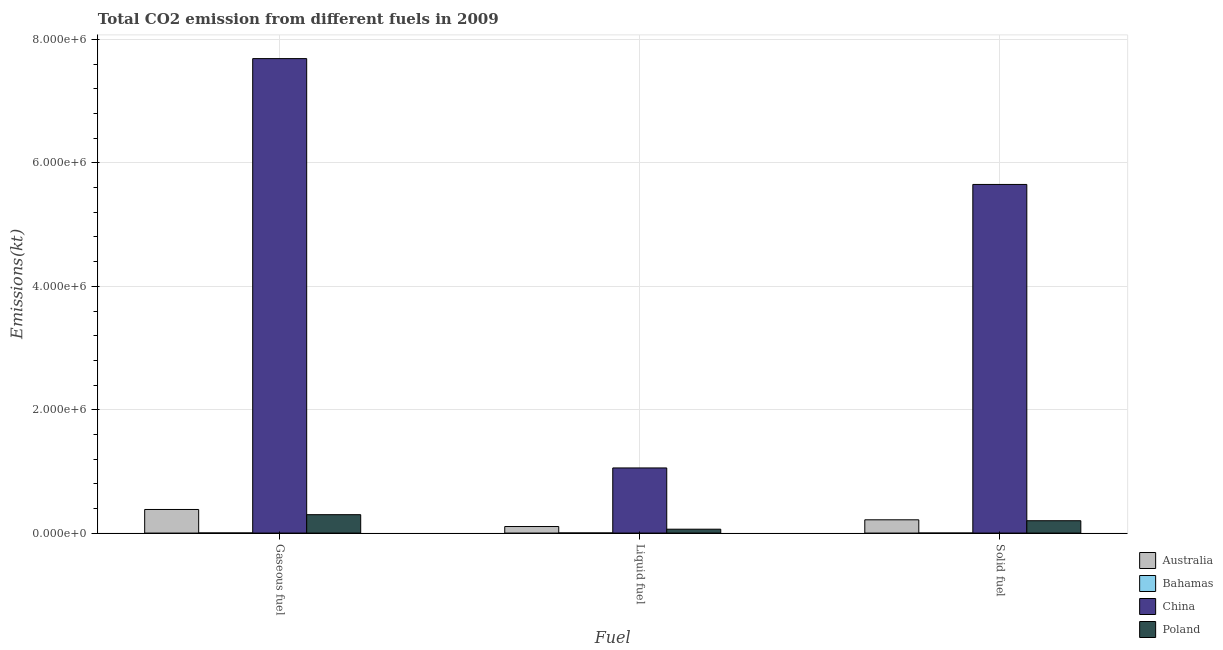How many different coloured bars are there?
Your response must be concise. 4. How many bars are there on the 3rd tick from the left?
Provide a succinct answer. 4. How many bars are there on the 1st tick from the right?
Ensure brevity in your answer.  4. What is the label of the 3rd group of bars from the left?
Give a very brief answer. Solid fuel. What is the amount of co2 emissions from gaseous fuel in China?
Offer a very short reply. 7.69e+06. Across all countries, what is the maximum amount of co2 emissions from liquid fuel?
Your answer should be very brief. 1.06e+06. Across all countries, what is the minimum amount of co2 emissions from liquid fuel?
Offer a terse response. 1635.48. In which country was the amount of co2 emissions from liquid fuel maximum?
Ensure brevity in your answer.  China. In which country was the amount of co2 emissions from solid fuel minimum?
Provide a short and direct response. Bahamas. What is the total amount of co2 emissions from liquid fuel in the graph?
Make the answer very short. 1.23e+06. What is the difference between the amount of co2 emissions from liquid fuel in Poland and that in Australia?
Ensure brevity in your answer.  -4.32e+04. What is the difference between the amount of co2 emissions from liquid fuel in Bahamas and the amount of co2 emissions from gaseous fuel in Australia?
Your answer should be very brief. -3.81e+05. What is the average amount of co2 emissions from solid fuel per country?
Give a very brief answer. 1.52e+06. What is the difference between the amount of co2 emissions from liquid fuel and amount of co2 emissions from gaseous fuel in Poland?
Provide a short and direct response. -2.35e+05. In how many countries, is the amount of co2 emissions from liquid fuel greater than 4000000 kt?
Provide a succinct answer. 0. What is the ratio of the amount of co2 emissions from liquid fuel in Bahamas to that in Australia?
Your response must be concise. 0.02. What is the difference between the highest and the second highest amount of co2 emissions from solid fuel?
Your response must be concise. 5.44e+06. What is the difference between the highest and the lowest amount of co2 emissions from liquid fuel?
Offer a terse response. 1.05e+06. In how many countries, is the amount of co2 emissions from liquid fuel greater than the average amount of co2 emissions from liquid fuel taken over all countries?
Offer a terse response. 1. Is the sum of the amount of co2 emissions from liquid fuel in China and Poland greater than the maximum amount of co2 emissions from gaseous fuel across all countries?
Offer a terse response. No. What does the 4th bar from the left in Solid fuel represents?
Your answer should be compact. Poland. Is it the case that in every country, the sum of the amount of co2 emissions from gaseous fuel and amount of co2 emissions from liquid fuel is greater than the amount of co2 emissions from solid fuel?
Your response must be concise. Yes. What is the title of the graph?
Keep it short and to the point. Total CO2 emission from different fuels in 2009. What is the label or title of the X-axis?
Make the answer very short. Fuel. What is the label or title of the Y-axis?
Make the answer very short. Emissions(kt). What is the Emissions(kt) of Australia in Gaseous fuel?
Provide a succinct answer. 3.82e+05. What is the Emissions(kt) of Bahamas in Gaseous fuel?
Ensure brevity in your answer.  1642.82. What is the Emissions(kt) in China in Gaseous fuel?
Your response must be concise. 7.69e+06. What is the Emissions(kt) in Poland in Gaseous fuel?
Keep it short and to the point. 2.98e+05. What is the Emissions(kt) of Australia in Liquid fuel?
Your answer should be very brief. 1.06e+05. What is the Emissions(kt) of Bahamas in Liquid fuel?
Ensure brevity in your answer.  1635.48. What is the Emissions(kt) of China in Liquid fuel?
Give a very brief answer. 1.06e+06. What is the Emissions(kt) in Poland in Liquid fuel?
Make the answer very short. 6.29e+04. What is the Emissions(kt) of Australia in Solid fuel?
Make the answer very short. 2.15e+05. What is the Emissions(kt) of Bahamas in Solid fuel?
Offer a terse response. 3.67. What is the Emissions(kt) of China in Solid fuel?
Provide a short and direct response. 5.65e+06. What is the Emissions(kt) in Poland in Solid fuel?
Make the answer very short. 2.00e+05. Across all Fuel, what is the maximum Emissions(kt) of Australia?
Keep it short and to the point. 3.82e+05. Across all Fuel, what is the maximum Emissions(kt) of Bahamas?
Offer a terse response. 1642.82. Across all Fuel, what is the maximum Emissions(kt) in China?
Make the answer very short. 7.69e+06. Across all Fuel, what is the maximum Emissions(kt) in Poland?
Your response must be concise. 2.98e+05. Across all Fuel, what is the minimum Emissions(kt) in Australia?
Your answer should be compact. 1.06e+05. Across all Fuel, what is the minimum Emissions(kt) in Bahamas?
Keep it short and to the point. 3.67. Across all Fuel, what is the minimum Emissions(kt) in China?
Provide a succinct answer. 1.06e+06. Across all Fuel, what is the minimum Emissions(kt) in Poland?
Your answer should be compact. 6.29e+04. What is the total Emissions(kt) in Australia in the graph?
Your answer should be very brief. 7.04e+05. What is the total Emissions(kt) of Bahamas in the graph?
Give a very brief answer. 3281.97. What is the total Emissions(kt) of China in the graph?
Your response must be concise. 1.44e+07. What is the total Emissions(kt) in Poland in the graph?
Your response must be concise. 5.61e+05. What is the difference between the Emissions(kt) in Australia in Gaseous fuel and that in Liquid fuel?
Your answer should be very brief. 2.76e+05. What is the difference between the Emissions(kt) in Bahamas in Gaseous fuel and that in Liquid fuel?
Your response must be concise. 7.33. What is the difference between the Emissions(kt) of China in Gaseous fuel and that in Liquid fuel?
Provide a succinct answer. 6.64e+06. What is the difference between the Emissions(kt) in Poland in Gaseous fuel and that in Liquid fuel?
Keep it short and to the point. 2.35e+05. What is the difference between the Emissions(kt) in Australia in Gaseous fuel and that in Solid fuel?
Your answer should be compact. 1.67e+05. What is the difference between the Emissions(kt) in Bahamas in Gaseous fuel and that in Solid fuel?
Offer a terse response. 1639.15. What is the difference between the Emissions(kt) of China in Gaseous fuel and that in Solid fuel?
Your answer should be compact. 2.04e+06. What is the difference between the Emissions(kt) in Poland in Gaseous fuel and that in Solid fuel?
Offer a very short reply. 9.82e+04. What is the difference between the Emissions(kt) of Australia in Liquid fuel and that in Solid fuel?
Provide a succinct answer. -1.09e+05. What is the difference between the Emissions(kt) in Bahamas in Liquid fuel and that in Solid fuel?
Give a very brief answer. 1631.82. What is the difference between the Emissions(kt) of China in Liquid fuel and that in Solid fuel?
Provide a short and direct response. -4.60e+06. What is the difference between the Emissions(kt) of Poland in Liquid fuel and that in Solid fuel?
Provide a short and direct response. -1.37e+05. What is the difference between the Emissions(kt) of Australia in Gaseous fuel and the Emissions(kt) of Bahamas in Liquid fuel?
Give a very brief answer. 3.81e+05. What is the difference between the Emissions(kt) in Australia in Gaseous fuel and the Emissions(kt) in China in Liquid fuel?
Make the answer very short. -6.73e+05. What is the difference between the Emissions(kt) in Australia in Gaseous fuel and the Emissions(kt) in Poland in Liquid fuel?
Your response must be concise. 3.20e+05. What is the difference between the Emissions(kt) of Bahamas in Gaseous fuel and the Emissions(kt) of China in Liquid fuel?
Provide a short and direct response. -1.05e+06. What is the difference between the Emissions(kt) in Bahamas in Gaseous fuel and the Emissions(kt) in Poland in Liquid fuel?
Provide a short and direct response. -6.12e+04. What is the difference between the Emissions(kt) of China in Gaseous fuel and the Emissions(kt) of Poland in Liquid fuel?
Offer a terse response. 7.63e+06. What is the difference between the Emissions(kt) in Australia in Gaseous fuel and the Emissions(kt) in Bahamas in Solid fuel?
Your answer should be very brief. 3.82e+05. What is the difference between the Emissions(kt) of Australia in Gaseous fuel and the Emissions(kt) of China in Solid fuel?
Your answer should be very brief. -5.27e+06. What is the difference between the Emissions(kt) of Australia in Gaseous fuel and the Emissions(kt) of Poland in Solid fuel?
Ensure brevity in your answer.  1.82e+05. What is the difference between the Emissions(kt) in Bahamas in Gaseous fuel and the Emissions(kt) in China in Solid fuel?
Offer a terse response. -5.65e+06. What is the difference between the Emissions(kt) in Bahamas in Gaseous fuel and the Emissions(kt) in Poland in Solid fuel?
Your answer should be very brief. -1.98e+05. What is the difference between the Emissions(kt) of China in Gaseous fuel and the Emissions(kt) of Poland in Solid fuel?
Your answer should be compact. 7.49e+06. What is the difference between the Emissions(kt) of Australia in Liquid fuel and the Emissions(kt) of Bahamas in Solid fuel?
Your response must be concise. 1.06e+05. What is the difference between the Emissions(kt) of Australia in Liquid fuel and the Emissions(kt) of China in Solid fuel?
Give a very brief answer. -5.55e+06. What is the difference between the Emissions(kt) of Australia in Liquid fuel and the Emissions(kt) of Poland in Solid fuel?
Provide a succinct answer. -9.40e+04. What is the difference between the Emissions(kt) of Bahamas in Liquid fuel and the Emissions(kt) of China in Solid fuel?
Your answer should be compact. -5.65e+06. What is the difference between the Emissions(kt) of Bahamas in Liquid fuel and the Emissions(kt) of Poland in Solid fuel?
Keep it short and to the point. -1.98e+05. What is the difference between the Emissions(kt) of China in Liquid fuel and the Emissions(kt) of Poland in Solid fuel?
Make the answer very short. 8.56e+05. What is the average Emissions(kt) in Australia per Fuel?
Make the answer very short. 2.35e+05. What is the average Emissions(kt) in Bahamas per Fuel?
Offer a terse response. 1093.99. What is the average Emissions(kt) in China per Fuel?
Your answer should be very brief. 4.80e+06. What is the average Emissions(kt) in Poland per Fuel?
Provide a succinct answer. 1.87e+05. What is the difference between the Emissions(kt) of Australia and Emissions(kt) of Bahamas in Gaseous fuel?
Keep it short and to the point. 3.81e+05. What is the difference between the Emissions(kt) of Australia and Emissions(kt) of China in Gaseous fuel?
Provide a short and direct response. -7.31e+06. What is the difference between the Emissions(kt) in Australia and Emissions(kt) in Poland in Gaseous fuel?
Your answer should be very brief. 8.42e+04. What is the difference between the Emissions(kt) of Bahamas and Emissions(kt) of China in Gaseous fuel?
Your response must be concise. -7.69e+06. What is the difference between the Emissions(kt) of Bahamas and Emissions(kt) of Poland in Gaseous fuel?
Ensure brevity in your answer.  -2.97e+05. What is the difference between the Emissions(kt) of China and Emissions(kt) of Poland in Gaseous fuel?
Your answer should be compact. 7.39e+06. What is the difference between the Emissions(kt) of Australia and Emissions(kt) of Bahamas in Liquid fuel?
Offer a very short reply. 1.04e+05. What is the difference between the Emissions(kt) of Australia and Emissions(kt) of China in Liquid fuel?
Your answer should be compact. -9.50e+05. What is the difference between the Emissions(kt) of Australia and Emissions(kt) of Poland in Liquid fuel?
Offer a very short reply. 4.32e+04. What is the difference between the Emissions(kt) in Bahamas and Emissions(kt) in China in Liquid fuel?
Make the answer very short. -1.05e+06. What is the difference between the Emissions(kt) of Bahamas and Emissions(kt) of Poland in Liquid fuel?
Ensure brevity in your answer.  -6.12e+04. What is the difference between the Emissions(kt) of China and Emissions(kt) of Poland in Liquid fuel?
Give a very brief answer. 9.93e+05. What is the difference between the Emissions(kt) of Australia and Emissions(kt) of Bahamas in Solid fuel?
Give a very brief answer. 2.15e+05. What is the difference between the Emissions(kt) in Australia and Emissions(kt) in China in Solid fuel?
Offer a very short reply. -5.44e+06. What is the difference between the Emissions(kt) of Australia and Emissions(kt) of Poland in Solid fuel?
Give a very brief answer. 1.51e+04. What is the difference between the Emissions(kt) of Bahamas and Emissions(kt) of China in Solid fuel?
Your response must be concise. -5.65e+06. What is the difference between the Emissions(kt) of Bahamas and Emissions(kt) of Poland in Solid fuel?
Provide a succinct answer. -2.00e+05. What is the difference between the Emissions(kt) in China and Emissions(kt) in Poland in Solid fuel?
Your answer should be compact. 5.45e+06. What is the ratio of the Emissions(kt) in Australia in Gaseous fuel to that in Liquid fuel?
Keep it short and to the point. 3.61. What is the ratio of the Emissions(kt) of China in Gaseous fuel to that in Liquid fuel?
Ensure brevity in your answer.  7.29. What is the ratio of the Emissions(kt) in Poland in Gaseous fuel to that in Liquid fuel?
Make the answer very short. 4.75. What is the ratio of the Emissions(kt) of Australia in Gaseous fuel to that in Solid fuel?
Ensure brevity in your answer.  1.78. What is the ratio of the Emissions(kt) in Bahamas in Gaseous fuel to that in Solid fuel?
Make the answer very short. 448. What is the ratio of the Emissions(kt) in China in Gaseous fuel to that in Solid fuel?
Give a very brief answer. 1.36. What is the ratio of the Emissions(kt) of Poland in Gaseous fuel to that in Solid fuel?
Provide a succinct answer. 1.49. What is the ratio of the Emissions(kt) in Australia in Liquid fuel to that in Solid fuel?
Keep it short and to the point. 0.49. What is the ratio of the Emissions(kt) in Bahamas in Liquid fuel to that in Solid fuel?
Make the answer very short. 446. What is the ratio of the Emissions(kt) of China in Liquid fuel to that in Solid fuel?
Offer a very short reply. 0.19. What is the ratio of the Emissions(kt) of Poland in Liquid fuel to that in Solid fuel?
Provide a short and direct response. 0.31. What is the difference between the highest and the second highest Emissions(kt) in Australia?
Your response must be concise. 1.67e+05. What is the difference between the highest and the second highest Emissions(kt) of Bahamas?
Your answer should be very brief. 7.33. What is the difference between the highest and the second highest Emissions(kt) in China?
Offer a terse response. 2.04e+06. What is the difference between the highest and the second highest Emissions(kt) of Poland?
Offer a terse response. 9.82e+04. What is the difference between the highest and the lowest Emissions(kt) in Australia?
Offer a terse response. 2.76e+05. What is the difference between the highest and the lowest Emissions(kt) of Bahamas?
Your answer should be very brief. 1639.15. What is the difference between the highest and the lowest Emissions(kt) of China?
Provide a succinct answer. 6.64e+06. What is the difference between the highest and the lowest Emissions(kt) of Poland?
Your response must be concise. 2.35e+05. 